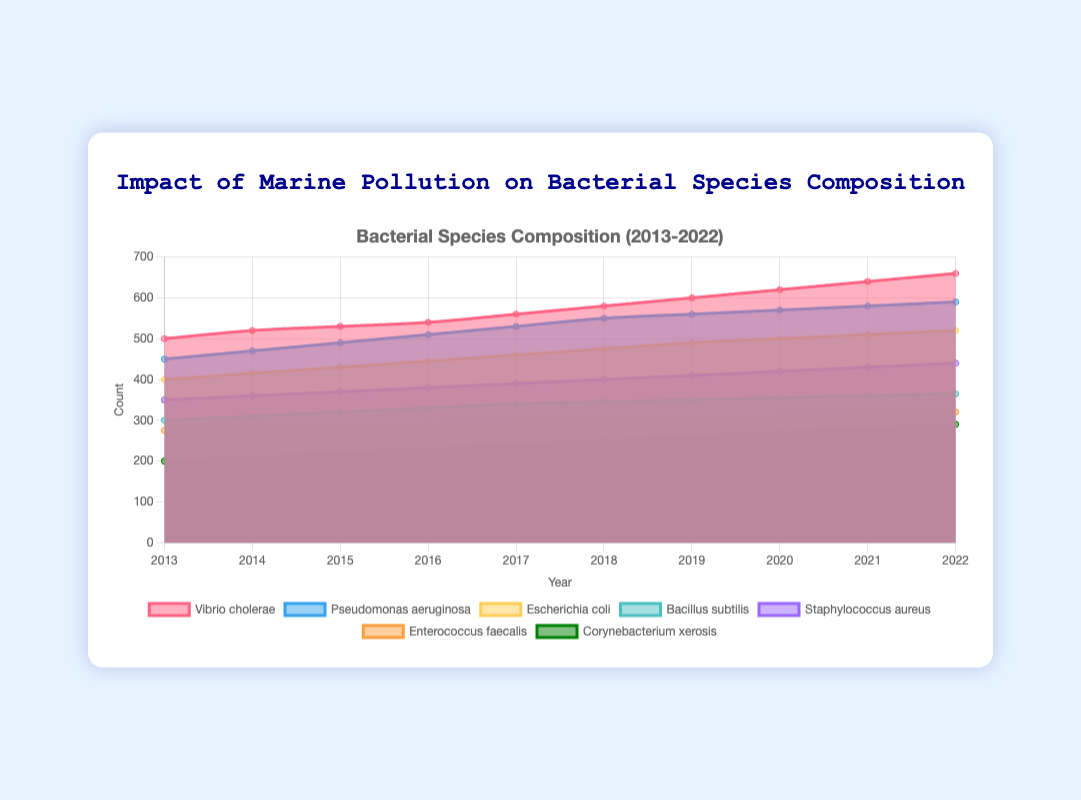What is the overall trend of Vibrio cholerae counts from 2013 to 2022? The overall counts of Vibrio cholerae increase steadily from 500 in 2013 to 660 in 2022. By observing the data points, it's clear that each year's count is higher than the previous year's.
Answer: Increasing Which species has the highest count in 2022? In 2022, the species with the highest count is Vibrio cholerae with a count of 660, compared to other species which all have lower counts.
Answer: Vibrio cholerae How does the count of Pseudomonas aeruginosa in 2013 compare to the count of Corynebacterium xerosis in 2022? The count of Pseudomonas aeruginosa in 2013 is 450, while the count of Corynebacterium xerosis in 2022 is 290. 450 is significantly higher than 290.
Answer: Pseudomonas aeruginosa count in 2013 is higher What has been the average yearly increase in the count of Escherichia coli over the last decade? The total increase in the counts of Escherichia coli from 2013 (400) to 2022 (520) is 120. Over 10 years, the average yearly increase is 120/10 = 12.
Answer: 12 Which species shows the smallest growth from 2013 to 2022? Corynebacterium xerosis grows from 200 in 2013 to 290 in 2022, which is an increase of 90. This is the smallest increase among the species.
Answer: Corynebacterium xerosis Between Bacillus subtilis and Staphylococcus aureus, which species had a higher count in 2017? In 2017, Bacillus subtilis has a count of 340, while Staphylococcus aureus has a count of 390. Thus, Staphylococcus aureus had a higher count.
Answer: Staphylococcus aureus By how much did the count of Enterococcus faecalis increase from 2015 to 2019? Enterococcus faecalis increased from 285 in 2015 to 305 in 2019. The increase can be calculated as 305 - 285 = 20.
Answer: 20 Is the trend in the counts of Bacillus subtilis stable, increasing, or decreasing over the years? The counts of Bacillus subtilis show a stable increasing trend over the years from 300 in 2013 to 365 in 2022 with no years of decrease.
Answer: Increasing What is the difference in counts between Vibrio cholerae and Escherichia coli in 2020? In 2020, Vibrio cholerae has a count of 620 and Escherichia coli has a count of 500. The difference is 620 - 500 = 120.
Answer: 120 